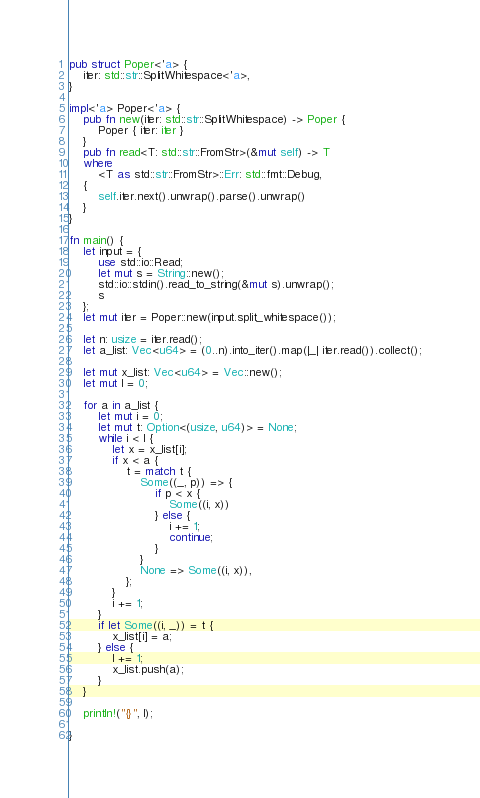Convert code to text. <code><loc_0><loc_0><loc_500><loc_500><_Rust_>pub struct Poper<'a> {
	iter: std::str::SplitWhitespace<'a>,
}

impl<'a> Poper<'a> {
	pub fn new(iter: std::str::SplitWhitespace) -> Poper {
		Poper { iter: iter }
	}
	pub fn read<T: std::str::FromStr>(&mut self) -> T
	where
		<T as std::str::FromStr>::Err: std::fmt::Debug,
	{
		self.iter.next().unwrap().parse().unwrap()
	}
}

fn main() {
	let input = {
		use std::io::Read;
		let mut s = String::new();
		std::io::stdin().read_to_string(&mut s).unwrap();
		s
	};
	let mut iter = Poper::new(input.split_whitespace());

	let n: usize = iter.read();
	let a_list: Vec<u64> = (0..n).into_iter().map(|_| iter.read()).collect();

	let mut x_list: Vec<u64> = Vec::new();
	let mut l = 0;

	for a in a_list {
		let mut i = 0;
		let mut t: Option<(usize, u64)> = None;
		while i < l {
			let x = x_list[i];
			if x < a {
				t = match t {
					Some((_, p)) => {
						if p < x {
							Some((i, x))
						} else {
							i += 1;
							continue;
						}
					}
					None => Some((i, x)),
				};
			}
			i += 1;
		}
		if let Some((i, _)) = t {
			x_list[i] = a;
		} else {
			l += 1;
			x_list.push(a);
		}
	}

	println!("{}", l);

}

</code> 